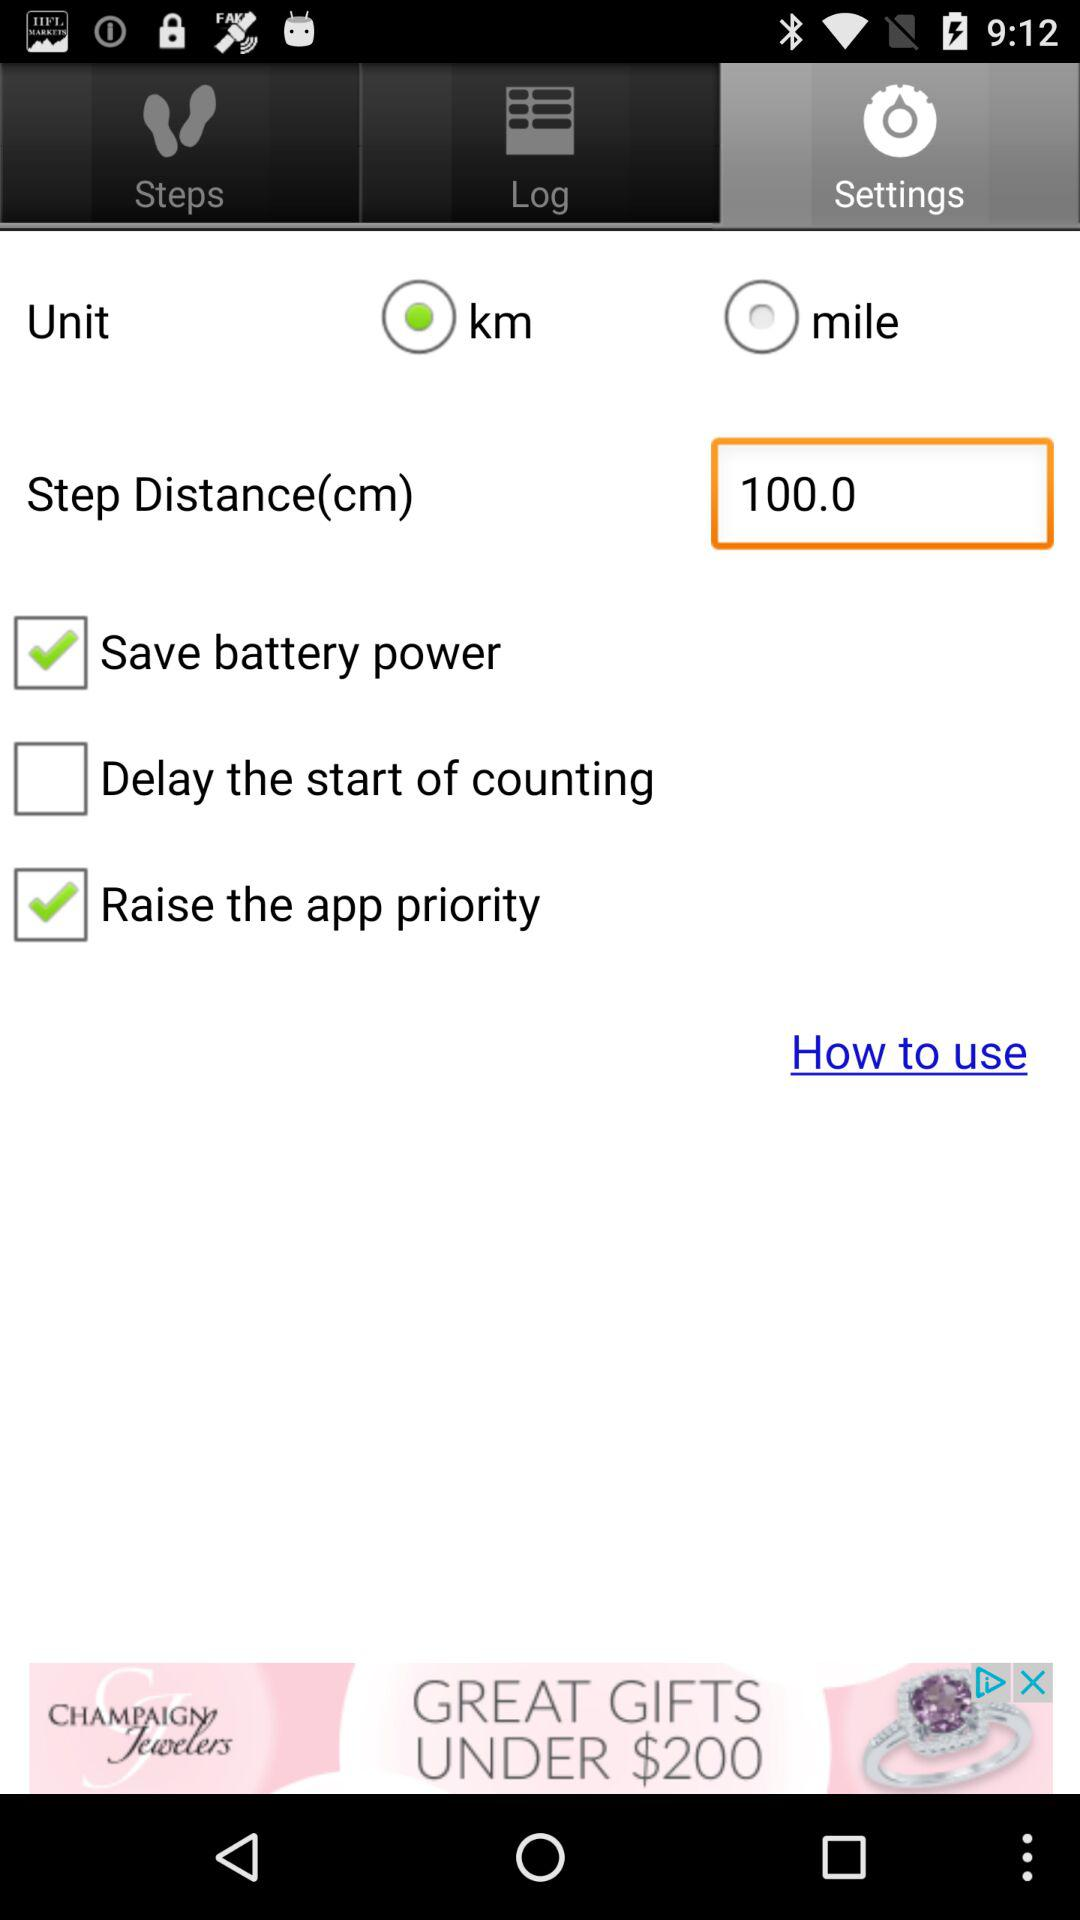Is the unit in km or miles? The unit is in km. 